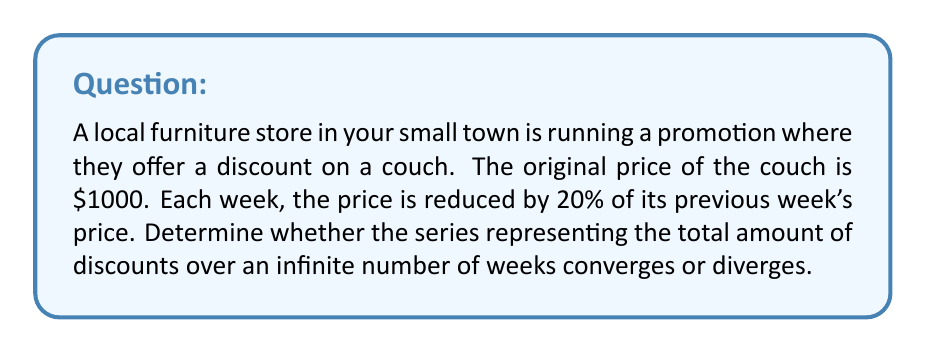Give your solution to this math problem. Let's approach this step-by-step:

1) First, we need to identify the geometric series. The discounts form a geometric series:

   $200 + 160 + 128 + 102.40 + ...$

2) To determine convergence, we need to find the first term $a$ and the common ratio $r$.

   $a = 200$ (20% of $1000)
   $r = 0.8$ (each term is 80% of the previous term)

3) For a geometric series $\sum_{n=1}^{\infty} ar^{n-1}$, it converges if and only if $|r| < 1$.

4) In this case, $r = 0.8$, and $|0.8| < 1$.

5) Therefore, the series converges.

6) We can find the sum of this convergent geometric series using the formula:

   $$S_{\infty} = \frac{a}{1-r} = \frac{200}{1-0.8} = \frac{200}{0.2} = 1000$$

This means the total amount of discounts over an infinite number of weeks is $1000, which makes sense as it's the original price of the couch.
Answer: The series converges. 